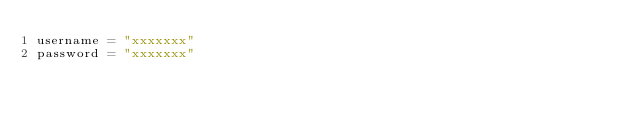<code> <loc_0><loc_0><loc_500><loc_500><_Python_>username = "xxxxxxx"
password = "xxxxxxx"
</code> 